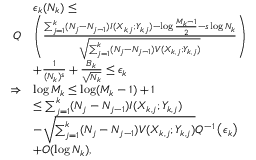<formula> <loc_0><loc_0><loc_500><loc_500>\begin{array} { r l } & { \epsilon _ { k } ( N _ { k } ) \leq } \\ { Q } & { \left ( \frac { \sum _ { j = 1 } ^ { k } ( N _ { j } - N _ { j - 1 } ) I ( X _ { k , j } ; Y _ { k , j } ) - \log \frac { M _ { k } - 1 } { 2 } - s \log N _ { k } } { \sqrt { \sum _ { j = 1 } ^ { k } ( N _ { j } - N _ { j - 1 } ) V ( X _ { k , j } ; Y _ { k , j } ) } } \right ) } \\ & { + \frac { 1 } { ( N _ { k } ) ^ { s } } + \frac { B _ { k } } { \sqrt { N _ { k } } } \leq \epsilon _ { k } } \\ { \Rightarrow } & { \log M _ { k } \leq \log ( M _ { k } - 1 ) + 1 } \\ & { \leq \sum _ { j = 1 } ^ { k } ( N _ { j } - N _ { j - 1 } ) I ( X _ { k , j } ; Y _ { k , j } ) } \\ & { - \sqrt { \sum _ { j = 1 } ^ { k } ( N _ { j } - N _ { j - 1 } ) V ( X _ { k , j } ; Y _ { k , j } ) } Q ^ { - 1 } \left ( \epsilon _ { k } \right ) } \\ & { + O ( \log N _ { k } ) , } \end{array}</formula> 